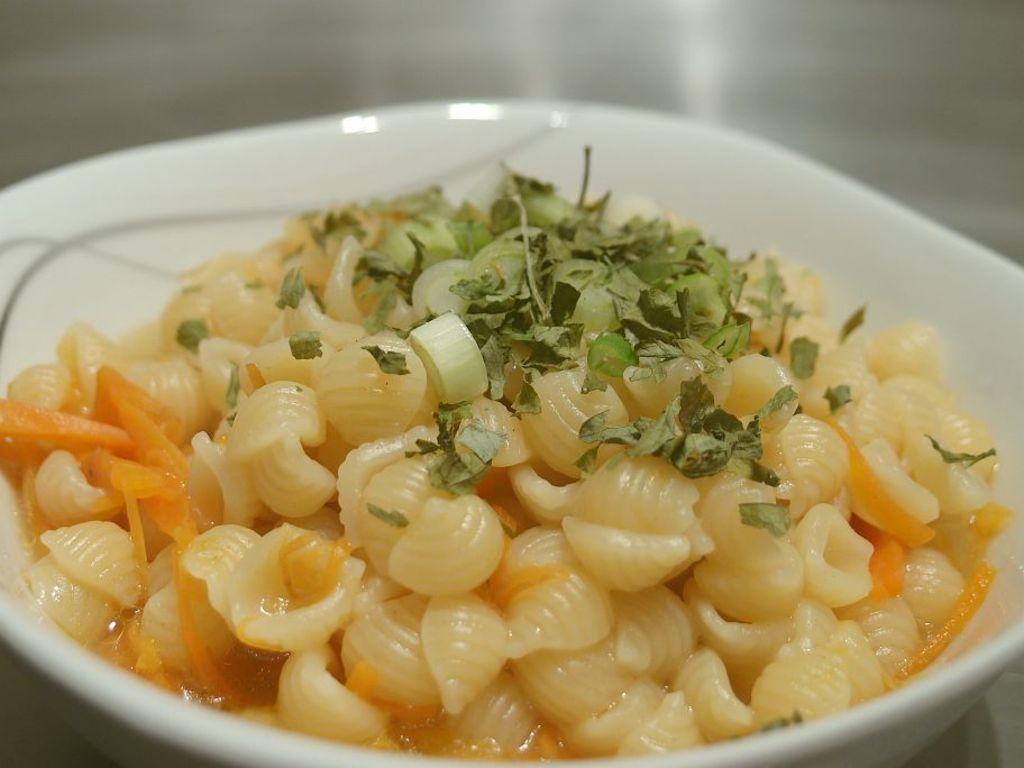In one or two sentences, can you explain what this image depicts? In this image we can see some food item which is placed in a bowl and there are some coriander leaves on it. 